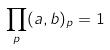Convert formula to latex. <formula><loc_0><loc_0><loc_500><loc_500>\prod _ { p } ( a , b ) _ { p } = 1</formula> 